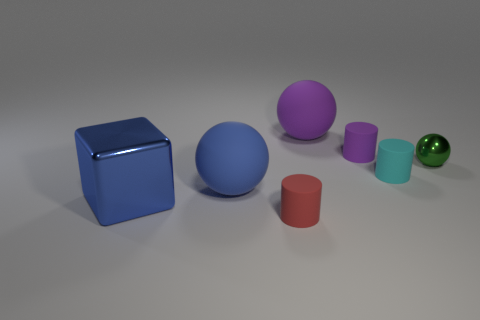What is the material of the blue cube that is to the left of the small rubber thing that is left of the tiny object behind the metal sphere?
Your response must be concise. Metal. Is the shape of the blue metallic object that is behind the tiny red matte cylinder the same as the tiny rubber thing that is behind the cyan rubber object?
Ensure brevity in your answer.  No. What number of other objects are there of the same material as the tiny red cylinder?
Provide a short and direct response. 4. Is the material of the small cylinder that is left of the purple sphere the same as the big ball that is on the left side of the tiny red matte object?
Keep it short and to the point. Yes. There is a cyan thing that is the same material as the big blue sphere; what is its shape?
Your answer should be very brief. Cylinder. Are there any other things that are the same color as the small metal ball?
Your answer should be compact. No. What number of big brown metal things are there?
Provide a succinct answer. 0. There is a small thing that is right of the tiny purple object and left of the small ball; what shape is it?
Give a very brief answer. Cylinder. There is a big object that is to the right of the small matte cylinder that is in front of the blue thing that is to the left of the large blue matte thing; what is its shape?
Ensure brevity in your answer.  Sphere. There is a object that is behind the green thing and to the left of the small purple object; what is it made of?
Make the answer very short. Rubber. 